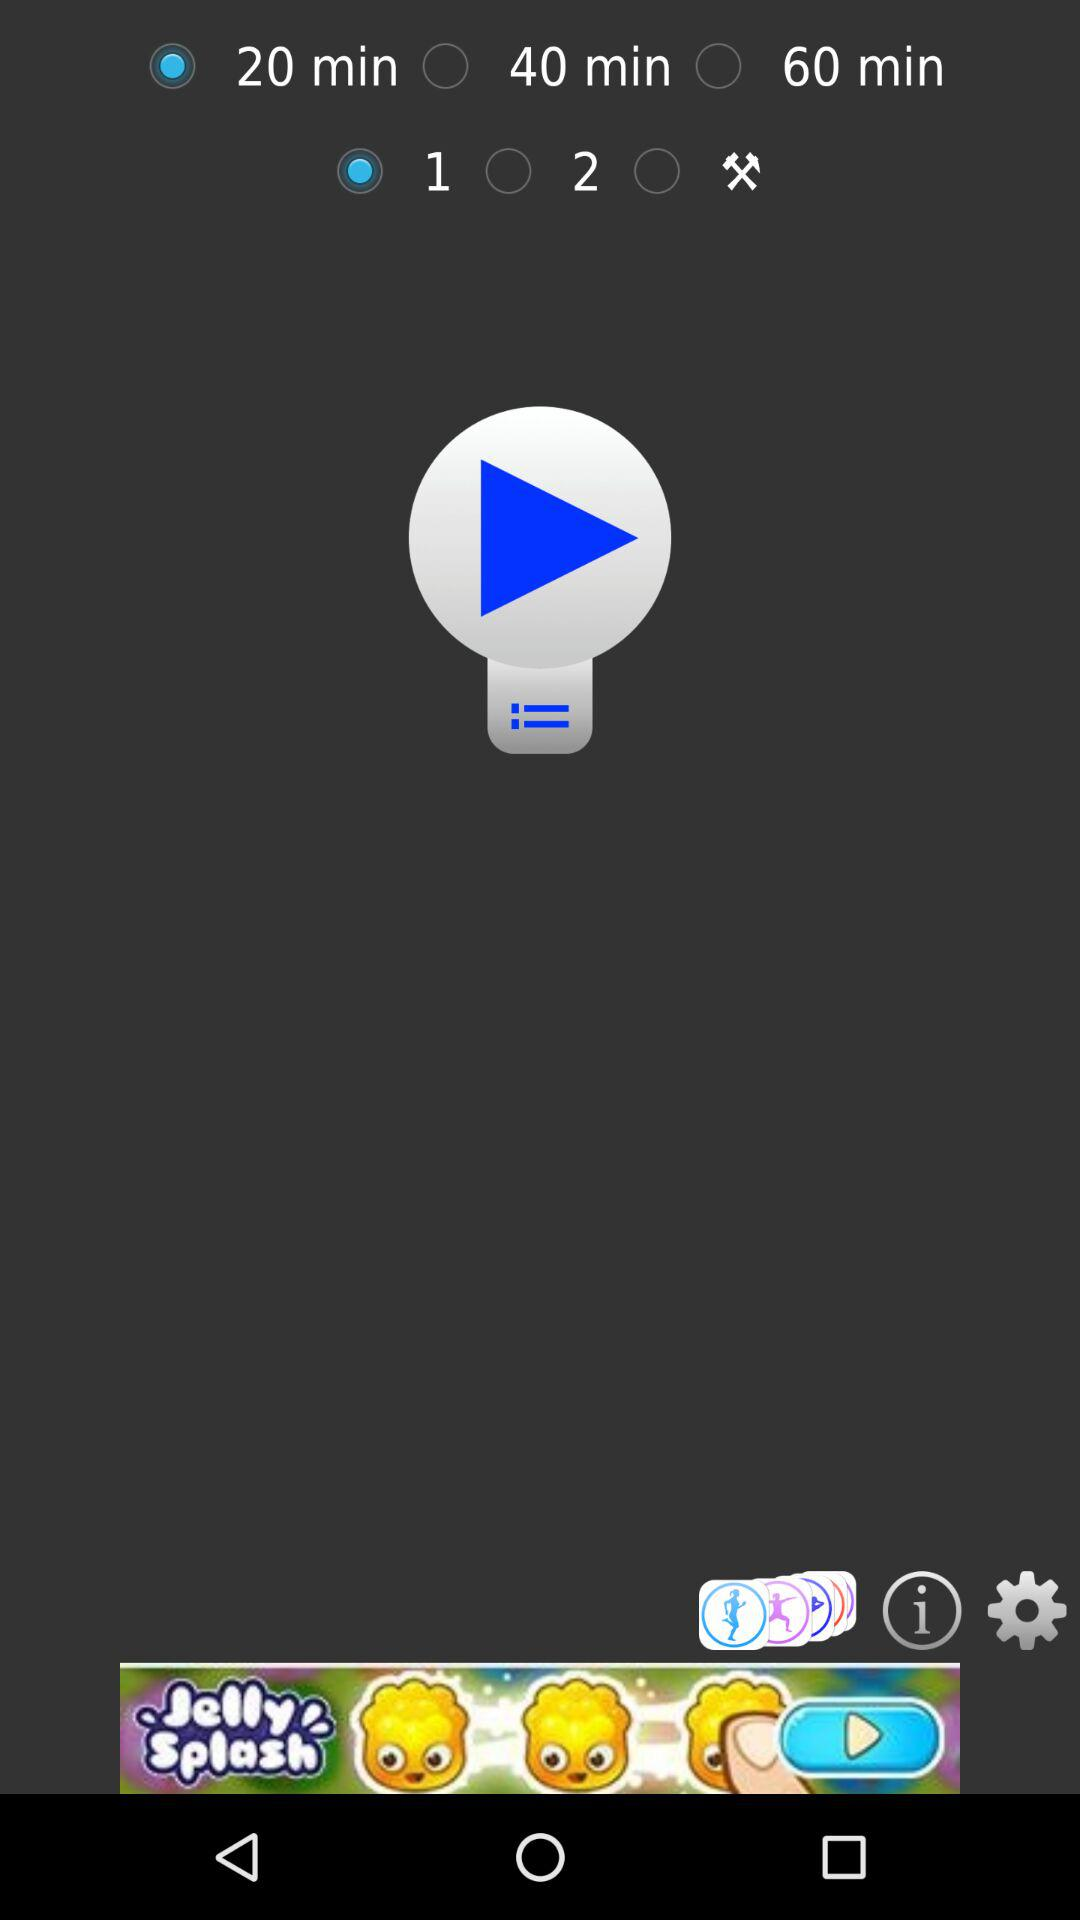How many minutes is the longest cooking time?
Answer the question using a single word or phrase. 60 